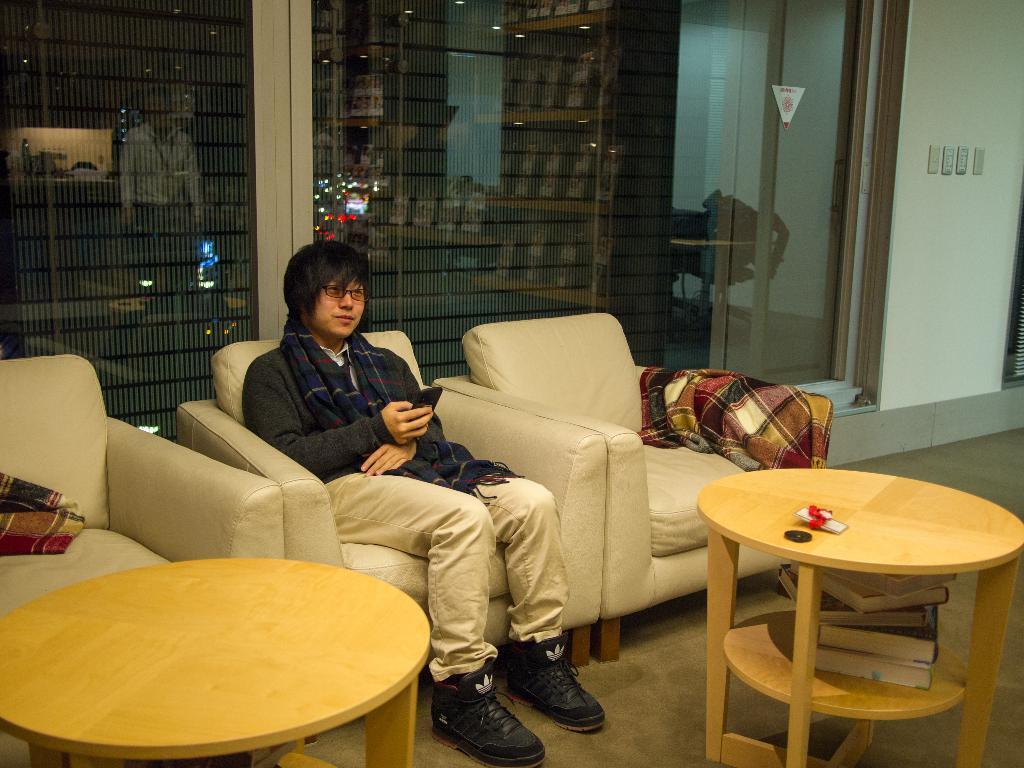In one or two sentences, can you explain what this image depicts? Here a man is sitting on the sofa and holding a mobile phone. He is wearing a shoes,trouser and sweater it's a table and there are books in that behind this there are books in that behind this man there is a glass wall inside this glass wall there is another person. 